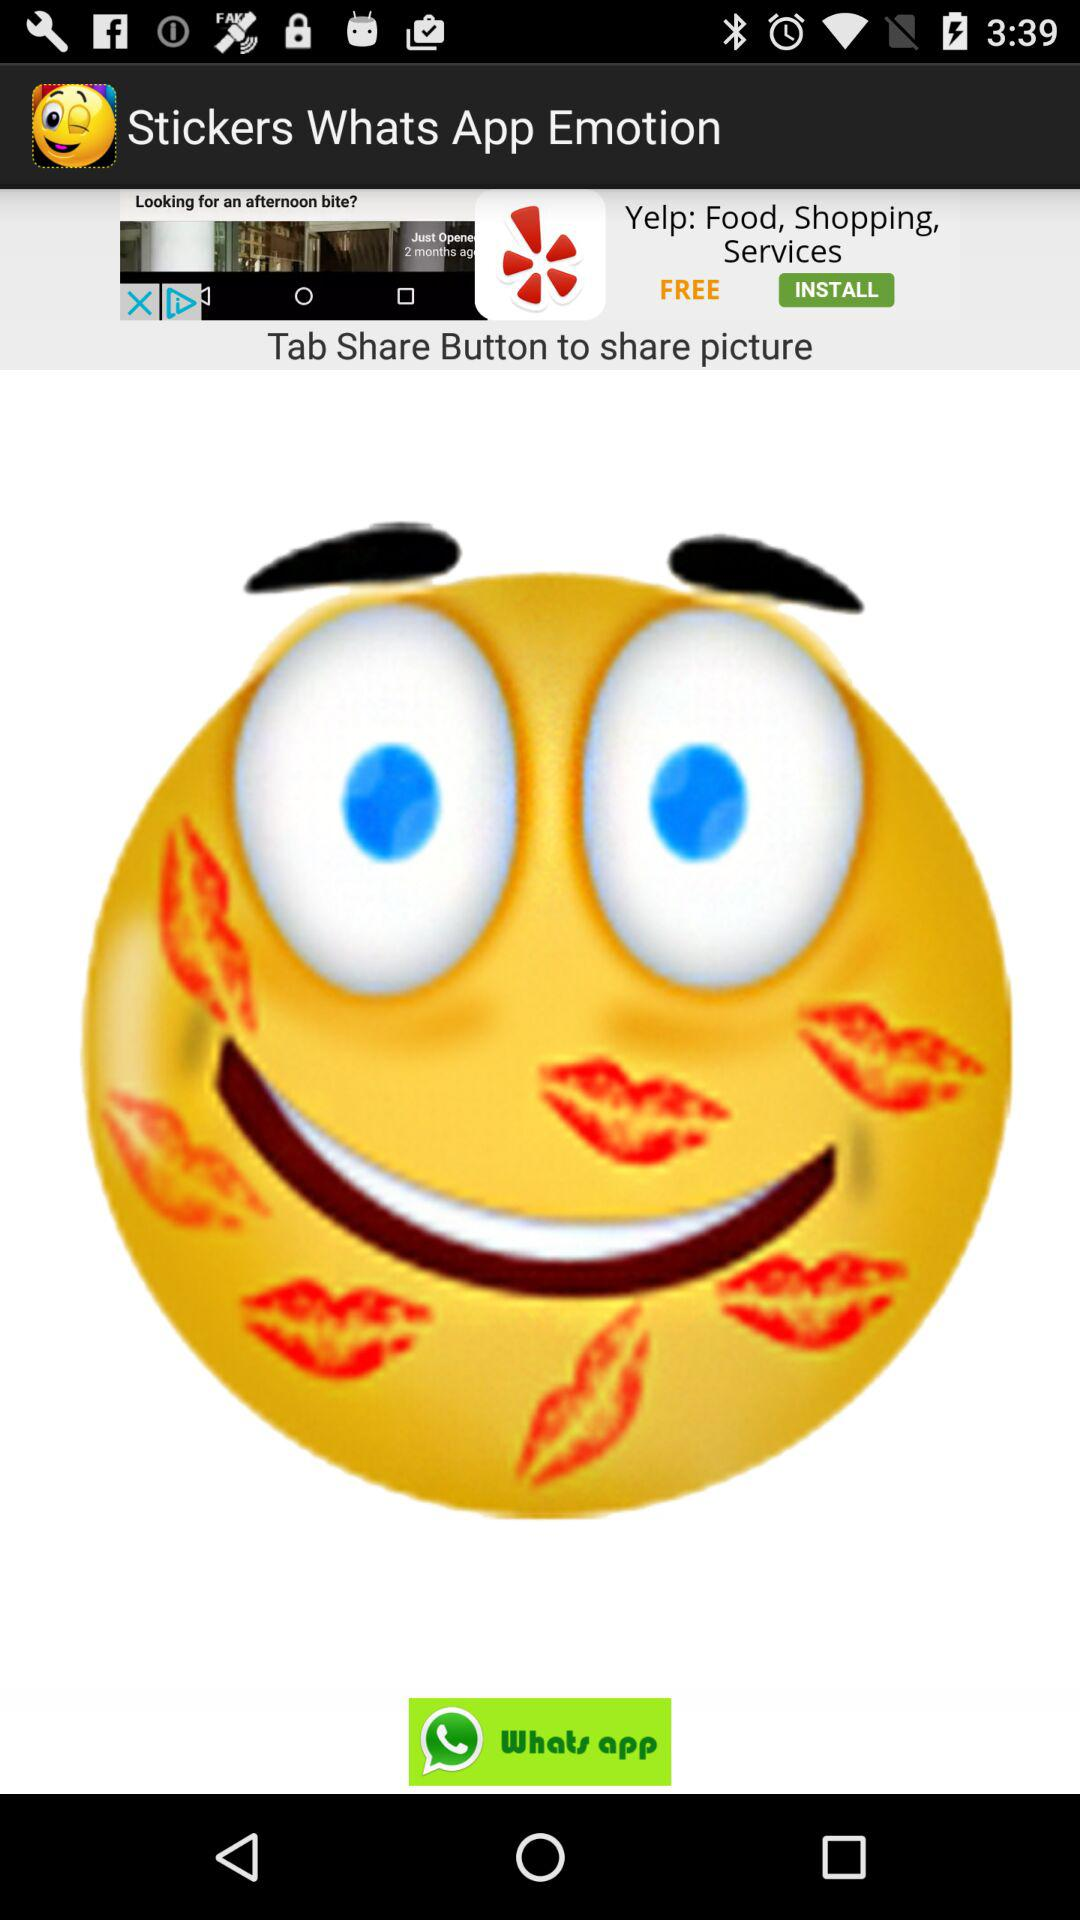What is the application name? The application name is "Stickers Whats App Emotion". 